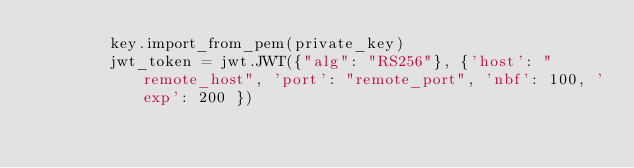<code> <loc_0><loc_0><loc_500><loc_500><_Python_>        key.import_from_pem(private_key)
        jwt_token = jwt.JWT({"alg": "RS256"}, {'host': "remote_host", 'port': "remote_port", 'nbf': 100, 'exp': 200 })</code> 